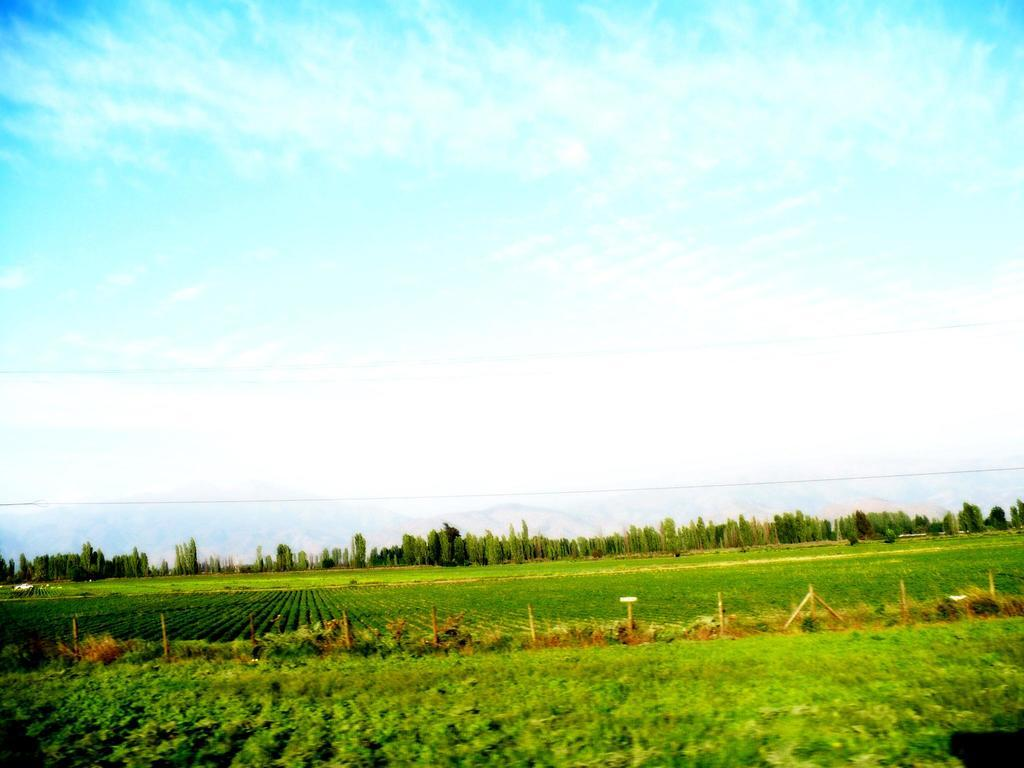What type of vegetation can be seen in the image? There are trees and plants in the image. What structures are present in the image? There are poles in the image. Are there any other objects visible in the image? Yes, there are other objects in the image. What is visible at the top of the image? The sky is visible at the top of the image. Where are the plants located in the image? Plants are present at the bottom of the image. What type of country is depicted in the image? There is no country depicted in the image; it features trees, plants, poles, and other objects. Can you tell me what time it is based on the clock in the image? There is no clock present in the image. 